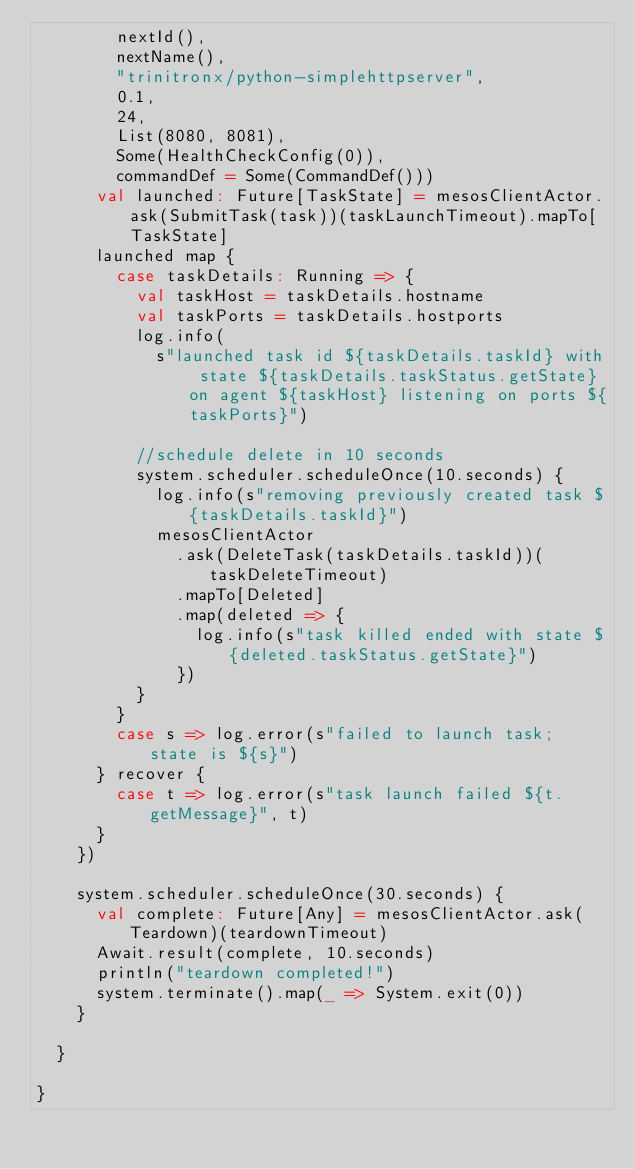<code> <loc_0><loc_0><loc_500><loc_500><_Scala_>        nextId(),
        nextName(),
        "trinitronx/python-simplehttpserver",
        0.1,
        24,
        List(8080, 8081),
        Some(HealthCheckConfig(0)),
        commandDef = Some(CommandDef()))
      val launched: Future[TaskState] = mesosClientActor.ask(SubmitTask(task))(taskLaunchTimeout).mapTo[TaskState]
      launched map {
        case taskDetails: Running => {
          val taskHost = taskDetails.hostname
          val taskPorts = taskDetails.hostports
          log.info(
            s"launched task id ${taskDetails.taskId} with state ${taskDetails.taskStatus.getState} on agent ${taskHost} listening on ports ${taskPorts}")

          //schedule delete in 10 seconds
          system.scheduler.scheduleOnce(10.seconds) {
            log.info(s"removing previously created task ${taskDetails.taskId}")
            mesosClientActor
              .ask(DeleteTask(taskDetails.taskId))(taskDeleteTimeout)
              .mapTo[Deleted]
              .map(deleted => {
                log.info(s"task killed ended with state ${deleted.taskStatus.getState}")
              })
          }
        }
        case s => log.error(s"failed to launch task; state is ${s}")
      } recover {
        case t => log.error(s"task launch failed ${t.getMessage}", t)
      }
    })

    system.scheduler.scheduleOnce(30.seconds) {
      val complete: Future[Any] = mesosClientActor.ask(Teardown)(teardownTimeout)
      Await.result(complete, 10.seconds)
      println("teardown completed!")
      system.terminate().map(_ => System.exit(0))
    }

  }

}
</code> 